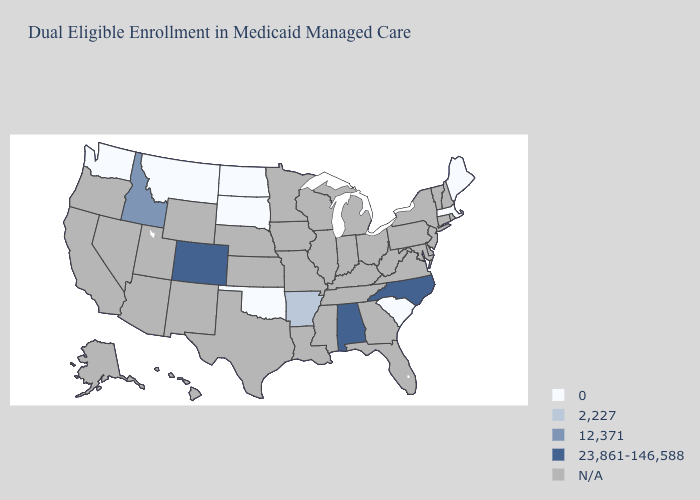Which states hav the highest value in the MidWest?
Short answer required. North Dakota, South Dakota. What is the lowest value in the South?
Write a very short answer. 0. What is the value of New York?
Quick response, please. N/A. Does Colorado have the lowest value in the USA?
Quick response, please. No. Among the states that border Connecticut , which have the lowest value?
Answer briefly. Massachusetts. Which states have the highest value in the USA?
Keep it brief. Alabama, Colorado, North Carolina. What is the value of Oregon?
Be succinct. N/A. What is the lowest value in states that border South Dakota?
Short answer required. 0. Name the states that have a value in the range 0?
Be succinct. Maine, Massachusetts, Montana, North Dakota, Oklahoma, South Carolina, South Dakota, Washington. Which states have the highest value in the USA?
Concise answer only. Alabama, Colorado, North Carolina. What is the value of Ohio?
Quick response, please. N/A. What is the value of Texas?
Answer briefly. N/A. Which states have the lowest value in the USA?
Answer briefly. Maine, Massachusetts, Montana, North Dakota, Oklahoma, South Carolina, South Dakota, Washington. Which states have the lowest value in the USA?
Give a very brief answer. Maine, Massachusetts, Montana, North Dakota, Oklahoma, South Carolina, South Dakota, Washington. 